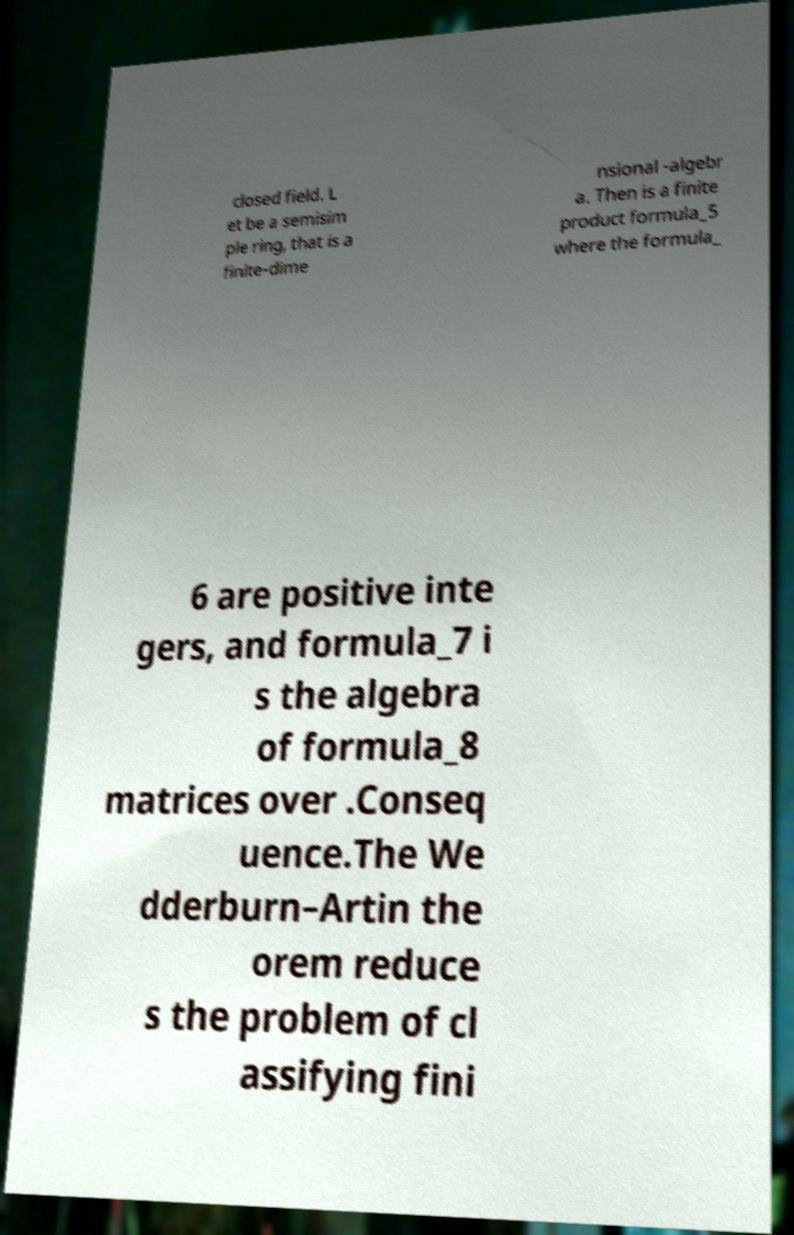Please read and relay the text visible in this image. What does it say? closed field. L et be a semisim ple ring, that is a finite-dime nsional -algebr a. Then is a finite product formula_5 where the formula_ 6 are positive inte gers, and formula_7 i s the algebra of formula_8 matrices over .Conseq uence.The We dderburn–Artin the orem reduce s the problem of cl assifying fini 